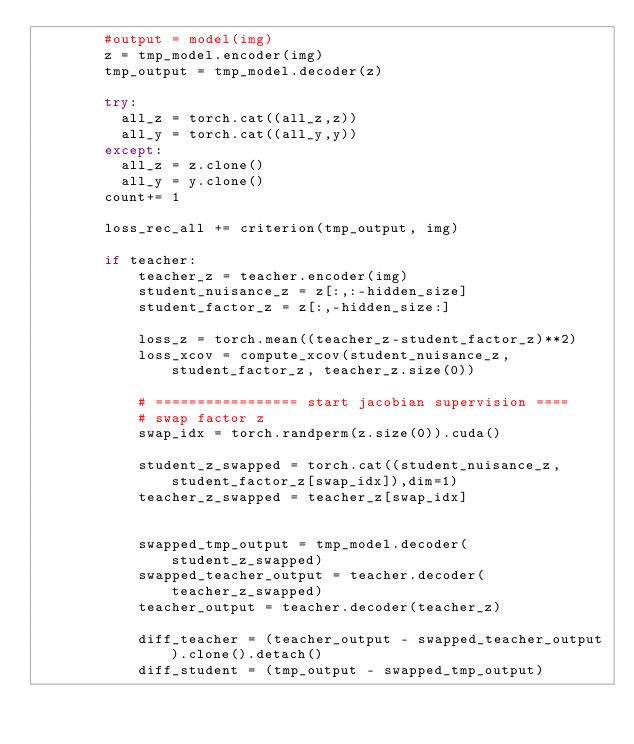Convert code to text. <code><loc_0><loc_0><loc_500><loc_500><_Python_>        #output = model(img)
        z = tmp_model.encoder(img)
        tmp_output = tmp_model.decoder(z)  

        try:
          all_z = torch.cat((all_z,z))
          all_y = torch.cat((all_y,y))
        except:
          all_z = z.clone()
          all_y = y.clone()
        count+= 1
        
        loss_rec_all += criterion(tmp_output, img)
        
        if teacher:
            teacher_z = teacher.encoder(img)
            student_nuisance_z = z[:,:-hidden_size]
            student_factor_z = z[:,-hidden_size:]
      
            loss_z = torch.mean((teacher_z-student_factor_z)**2)
            loss_xcov = compute_xcov(student_nuisance_z, student_factor_z, teacher_z.size(0))

            # ================= start jacobian supervision ====
            # swap factor z
            swap_idx = torch.randperm(z.size(0)).cuda()
    
            student_z_swapped = torch.cat((student_nuisance_z,student_factor_z[swap_idx]),dim=1)
            teacher_z_swapped = teacher_z[swap_idx]
    
            
            swapped_tmp_output = tmp_model.decoder(student_z_swapped)
            swapped_teacher_output = teacher.decoder(teacher_z_swapped)
            teacher_output = teacher.decoder(teacher_z)
            
            diff_teacher = (teacher_output - swapped_teacher_output).clone().detach()
            diff_student = (tmp_output - swapped_tmp_output)
    </code> 